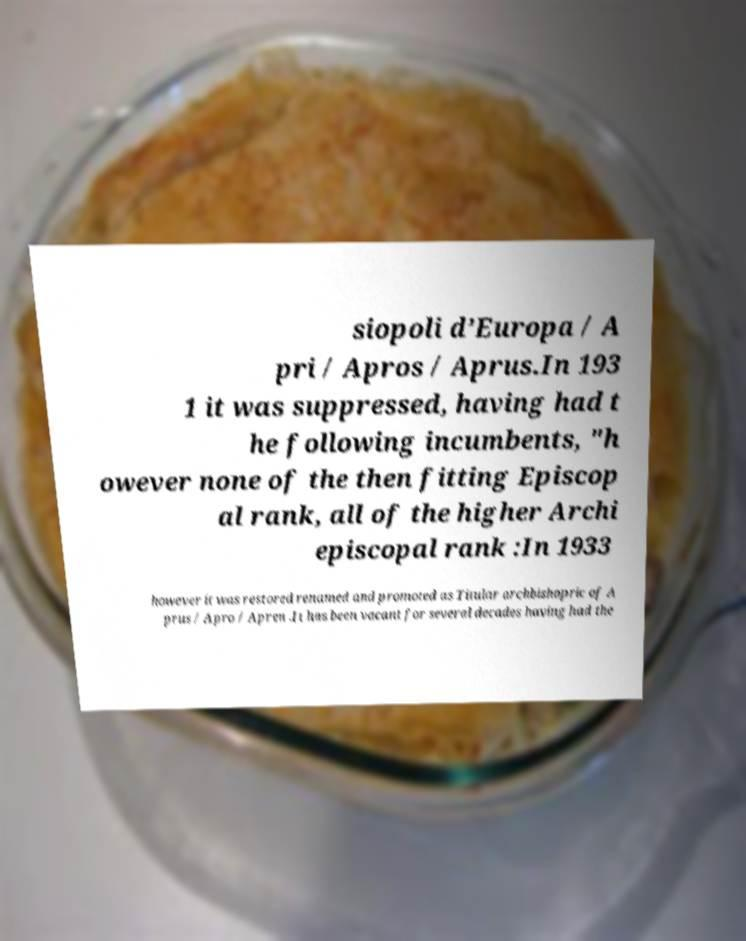Can you read and provide the text displayed in the image?This photo seems to have some interesting text. Can you extract and type it out for me? siopoli d’Europa / A pri / Apros / Aprus.In 193 1 it was suppressed, having had t he following incumbents, "h owever none of the then fitting Episcop al rank, all of the higher Archi episcopal rank :In 1933 however it was restored renamed and promoted as Titular archbishopric of A prus / Apro / Apren .It has been vacant for several decades having had the 